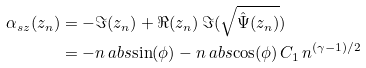<formula> <loc_0><loc_0><loc_500><loc_500>\alpha _ { s z } ( z _ { n } ) & = - \Im ( z _ { n } ) + \Re ( z _ { n } ) \, \Im ( \sqrt { \hat { \Psi } ( z _ { n } ) } ) \\ & = - n \ a b s { \sin ( \phi ) } - n \ a b s { \cos ( \phi ) } \, C _ { 1 } \, n ^ { ( \gamma - 1 ) / 2 }</formula> 